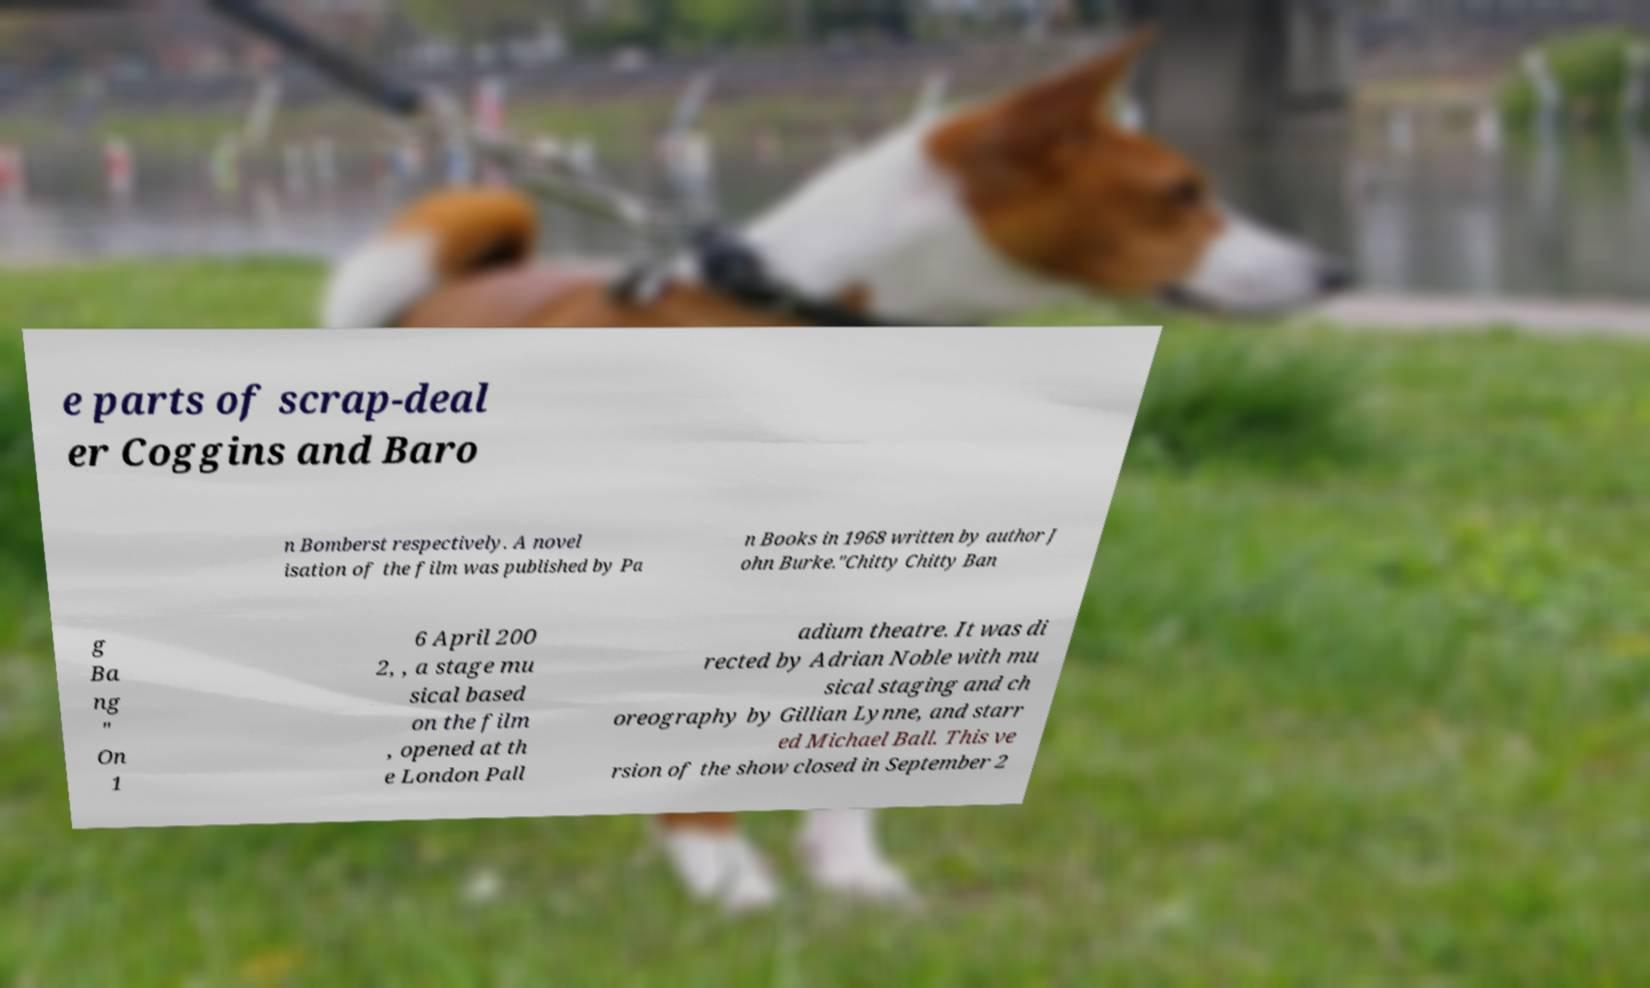Could you extract and type out the text from this image? e parts of scrap-deal er Coggins and Baro n Bomberst respectively. A novel isation of the film was published by Pa n Books in 1968 written by author J ohn Burke."Chitty Chitty Ban g Ba ng " On 1 6 April 200 2, , a stage mu sical based on the film , opened at th e London Pall adium theatre. It was di rected by Adrian Noble with mu sical staging and ch oreography by Gillian Lynne, and starr ed Michael Ball. This ve rsion of the show closed in September 2 